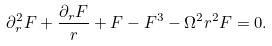<formula> <loc_0><loc_0><loc_500><loc_500>\partial _ { r } ^ { 2 } F + \frac { \partial _ { r } F } r + F - F ^ { 3 } - \Omega ^ { 2 } r ^ { 2 } F = 0 .</formula> 